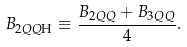<formula> <loc_0><loc_0><loc_500><loc_500>B _ { 2 Q Q \text  H} \equiv \frac{B_{2QQ} + B _ { 3 Q Q } } { 4 } .</formula> 